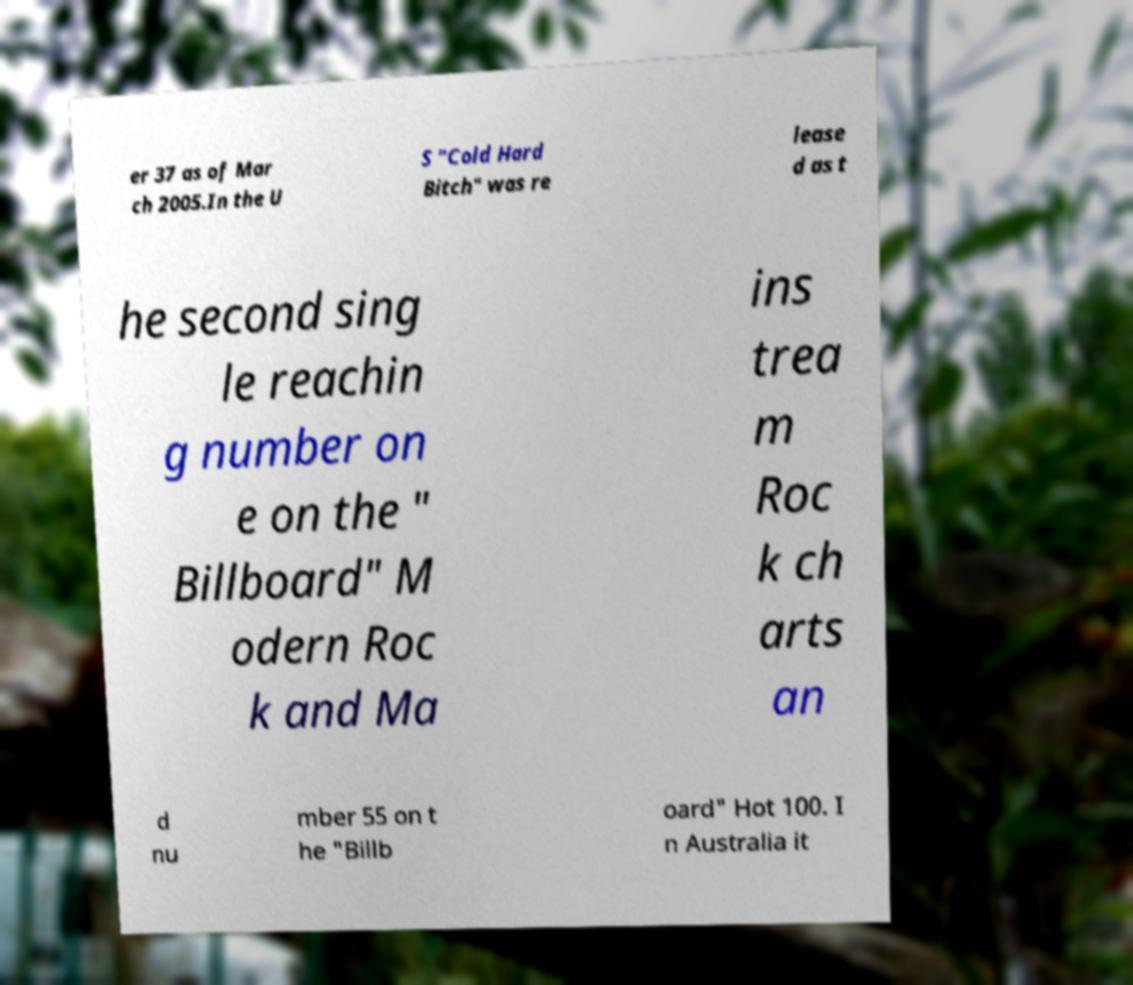Please identify and transcribe the text found in this image. er 37 as of Mar ch 2005.In the U S "Cold Hard Bitch" was re lease d as t he second sing le reachin g number on e on the " Billboard" M odern Roc k and Ma ins trea m Roc k ch arts an d nu mber 55 on t he "Billb oard" Hot 100. I n Australia it 